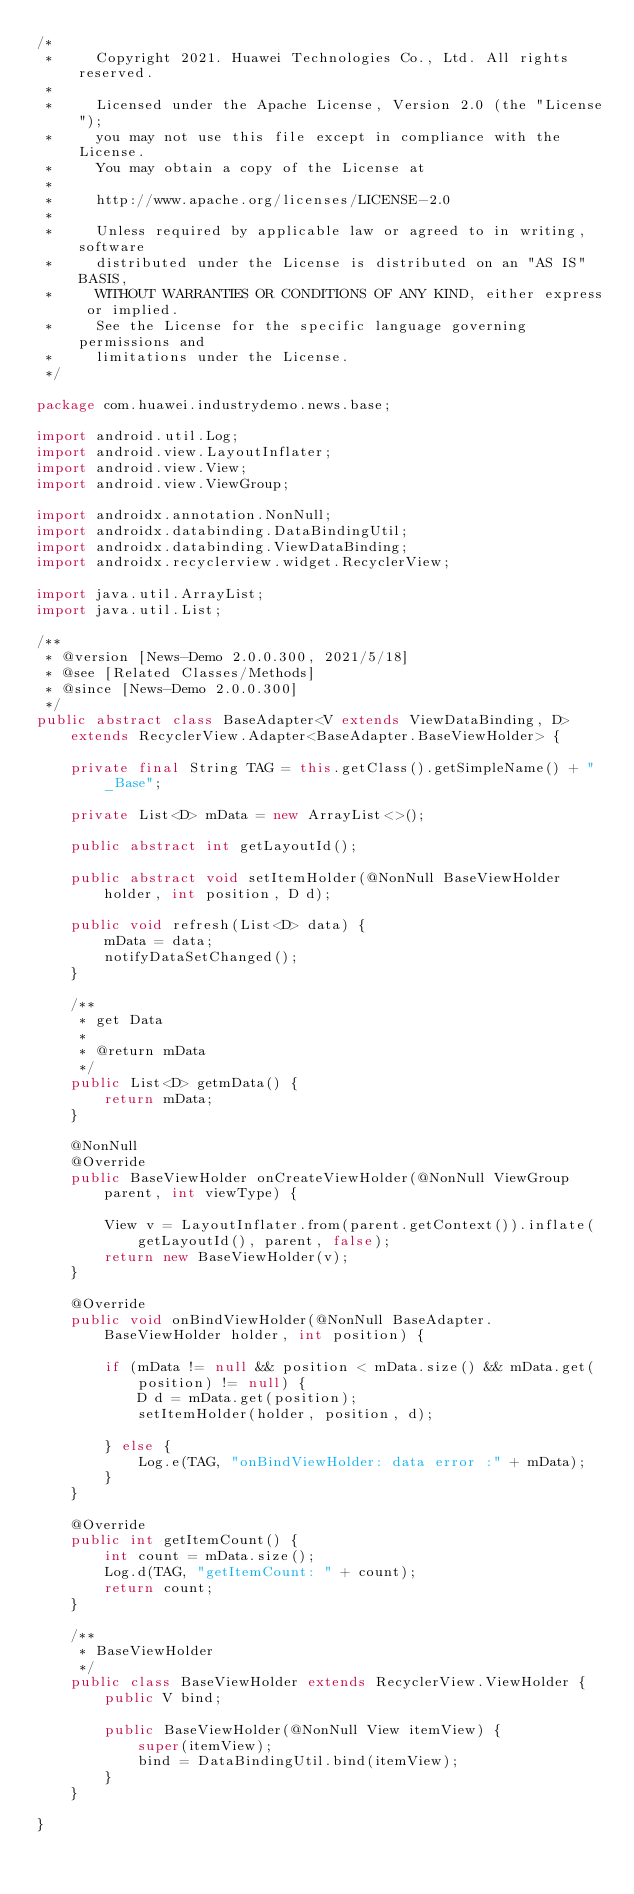Convert code to text. <code><loc_0><loc_0><loc_500><loc_500><_Java_>/*
 *     Copyright 2021. Huawei Technologies Co., Ltd. All rights reserved.
 *
 *     Licensed under the Apache License, Version 2.0 (the "License");
 *     you may not use this file except in compliance with the License.
 *     You may obtain a copy of the License at
 *
 *     http://www.apache.org/licenses/LICENSE-2.0
 *
 *     Unless required by applicable law or agreed to in writing, software
 *     distributed under the License is distributed on an "AS IS" BASIS,
 *     WITHOUT WARRANTIES OR CONDITIONS OF ANY KIND, either express or implied.
 *     See the License for the specific language governing permissions and
 *     limitations under the License.
 */

package com.huawei.industrydemo.news.base;

import android.util.Log;
import android.view.LayoutInflater;
import android.view.View;
import android.view.ViewGroup;

import androidx.annotation.NonNull;
import androidx.databinding.DataBindingUtil;
import androidx.databinding.ViewDataBinding;
import androidx.recyclerview.widget.RecyclerView;

import java.util.ArrayList;
import java.util.List;

/**
 * @version [News-Demo 2.0.0.300, 2021/5/18]
 * @see [Related Classes/Methods]
 * @since [News-Demo 2.0.0.300]
 */
public abstract class BaseAdapter<V extends ViewDataBinding, D>
    extends RecyclerView.Adapter<BaseAdapter.BaseViewHolder> {

    private final String TAG = this.getClass().getSimpleName() + "_Base";

    private List<D> mData = new ArrayList<>();

    public abstract int getLayoutId();

    public abstract void setItemHolder(@NonNull BaseViewHolder holder, int position, D d);

    public void refresh(List<D> data) {
        mData = data;
        notifyDataSetChanged();
    }

    /**
     * get Data
     * 
     * @return mData
     */
    public List<D> getmData() {
        return mData;
    }

    @NonNull
    @Override
    public BaseViewHolder onCreateViewHolder(@NonNull ViewGroup parent, int viewType) {

        View v = LayoutInflater.from(parent.getContext()).inflate(getLayoutId(), parent, false);
        return new BaseViewHolder(v);
    }

    @Override
    public void onBindViewHolder(@NonNull BaseAdapter.BaseViewHolder holder, int position) {

        if (mData != null && position < mData.size() && mData.get(position) != null) {
            D d = mData.get(position);
            setItemHolder(holder, position, d);

        } else {
            Log.e(TAG, "onBindViewHolder: data error :" + mData);
        }
    }

    @Override
    public int getItemCount() {
        int count = mData.size();
        Log.d(TAG, "getItemCount: " + count);
        return count;
    }

    /**
     * BaseViewHolder
     */
    public class BaseViewHolder extends RecyclerView.ViewHolder {
        public V bind;

        public BaseViewHolder(@NonNull View itemView) {
            super(itemView);
            bind = DataBindingUtil.bind(itemView);
        }
    }

}
</code> 